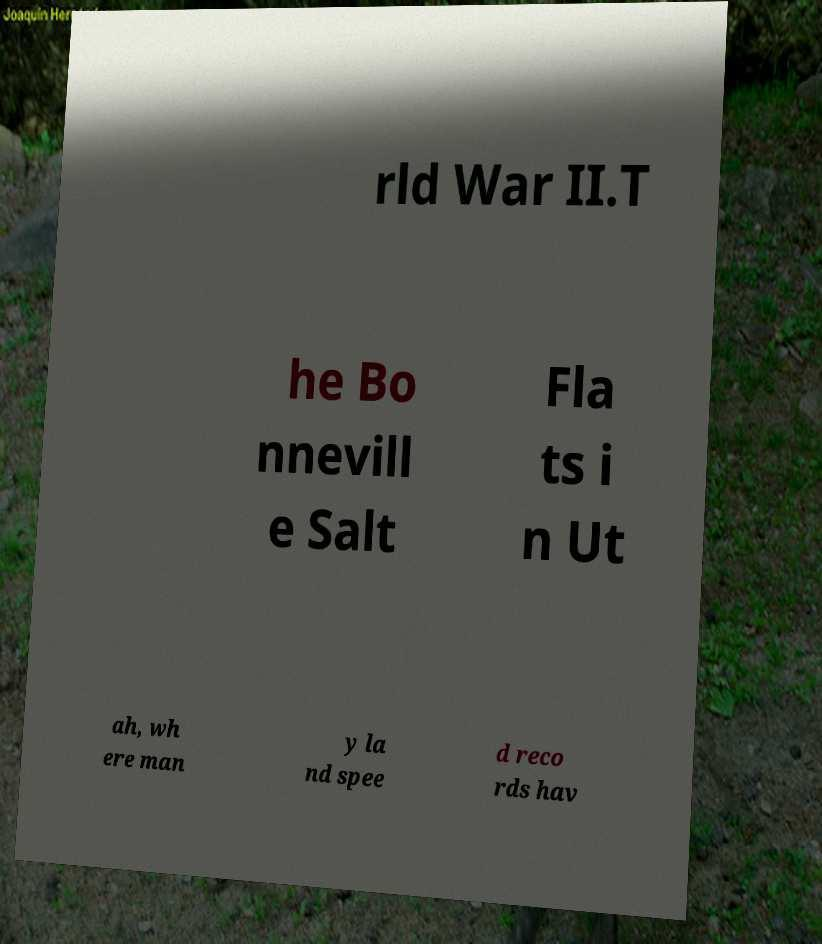Could you assist in decoding the text presented in this image and type it out clearly? rld War II.T he Bo nnevill e Salt Fla ts i n Ut ah, wh ere man y la nd spee d reco rds hav 